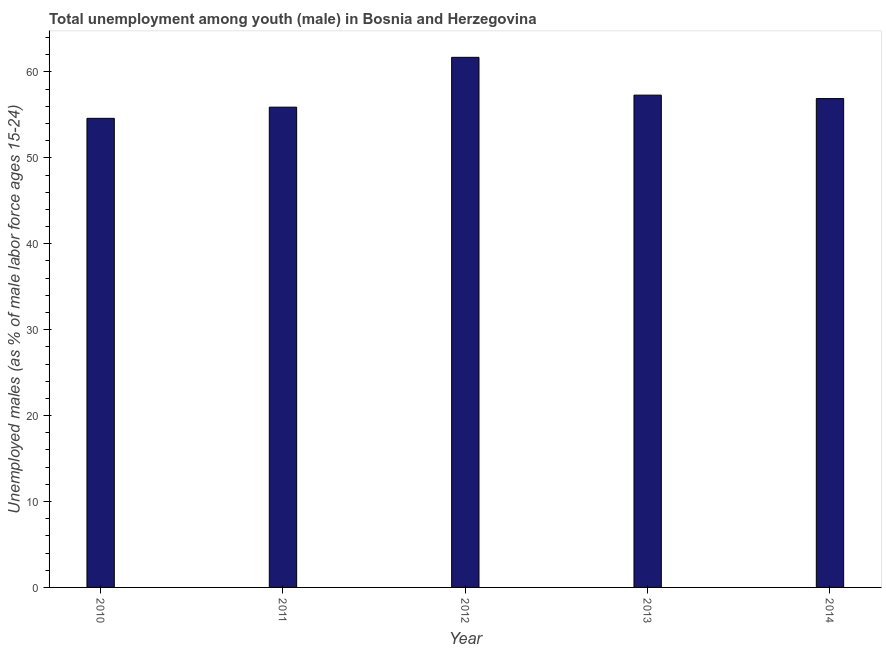What is the title of the graph?
Provide a succinct answer. Total unemployment among youth (male) in Bosnia and Herzegovina. What is the label or title of the Y-axis?
Offer a very short reply. Unemployed males (as % of male labor force ages 15-24). What is the unemployed male youth population in 2013?
Your response must be concise. 57.3. Across all years, what is the maximum unemployed male youth population?
Provide a short and direct response. 61.7. Across all years, what is the minimum unemployed male youth population?
Provide a succinct answer. 54.6. What is the sum of the unemployed male youth population?
Keep it short and to the point. 286.4. What is the average unemployed male youth population per year?
Provide a succinct answer. 57.28. What is the median unemployed male youth population?
Offer a very short reply. 56.9. What is the ratio of the unemployed male youth population in 2010 to that in 2011?
Make the answer very short. 0.98. Is the unemployed male youth population in 2010 less than that in 2011?
Your answer should be compact. Yes. Is the difference between the unemployed male youth population in 2013 and 2014 greater than the difference between any two years?
Provide a succinct answer. No. In how many years, is the unemployed male youth population greater than the average unemployed male youth population taken over all years?
Offer a terse response. 2. Are the values on the major ticks of Y-axis written in scientific E-notation?
Ensure brevity in your answer.  No. What is the Unemployed males (as % of male labor force ages 15-24) in 2010?
Your answer should be compact. 54.6. What is the Unemployed males (as % of male labor force ages 15-24) in 2011?
Keep it short and to the point. 55.9. What is the Unemployed males (as % of male labor force ages 15-24) of 2012?
Your response must be concise. 61.7. What is the Unemployed males (as % of male labor force ages 15-24) of 2013?
Give a very brief answer. 57.3. What is the Unemployed males (as % of male labor force ages 15-24) in 2014?
Ensure brevity in your answer.  56.9. What is the difference between the Unemployed males (as % of male labor force ages 15-24) in 2010 and 2012?
Ensure brevity in your answer.  -7.1. What is the difference between the Unemployed males (as % of male labor force ages 15-24) in 2010 and 2013?
Your answer should be very brief. -2.7. What is the difference between the Unemployed males (as % of male labor force ages 15-24) in 2011 and 2014?
Your response must be concise. -1. What is the difference between the Unemployed males (as % of male labor force ages 15-24) in 2013 and 2014?
Make the answer very short. 0.4. What is the ratio of the Unemployed males (as % of male labor force ages 15-24) in 2010 to that in 2012?
Your answer should be very brief. 0.89. What is the ratio of the Unemployed males (as % of male labor force ages 15-24) in 2010 to that in 2013?
Your answer should be very brief. 0.95. What is the ratio of the Unemployed males (as % of male labor force ages 15-24) in 2010 to that in 2014?
Give a very brief answer. 0.96. What is the ratio of the Unemployed males (as % of male labor force ages 15-24) in 2011 to that in 2012?
Give a very brief answer. 0.91. What is the ratio of the Unemployed males (as % of male labor force ages 15-24) in 2011 to that in 2013?
Ensure brevity in your answer.  0.98. What is the ratio of the Unemployed males (as % of male labor force ages 15-24) in 2011 to that in 2014?
Offer a very short reply. 0.98. What is the ratio of the Unemployed males (as % of male labor force ages 15-24) in 2012 to that in 2013?
Ensure brevity in your answer.  1.08. What is the ratio of the Unemployed males (as % of male labor force ages 15-24) in 2012 to that in 2014?
Your answer should be compact. 1.08. What is the ratio of the Unemployed males (as % of male labor force ages 15-24) in 2013 to that in 2014?
Provide a short and direct response. 1.01. 